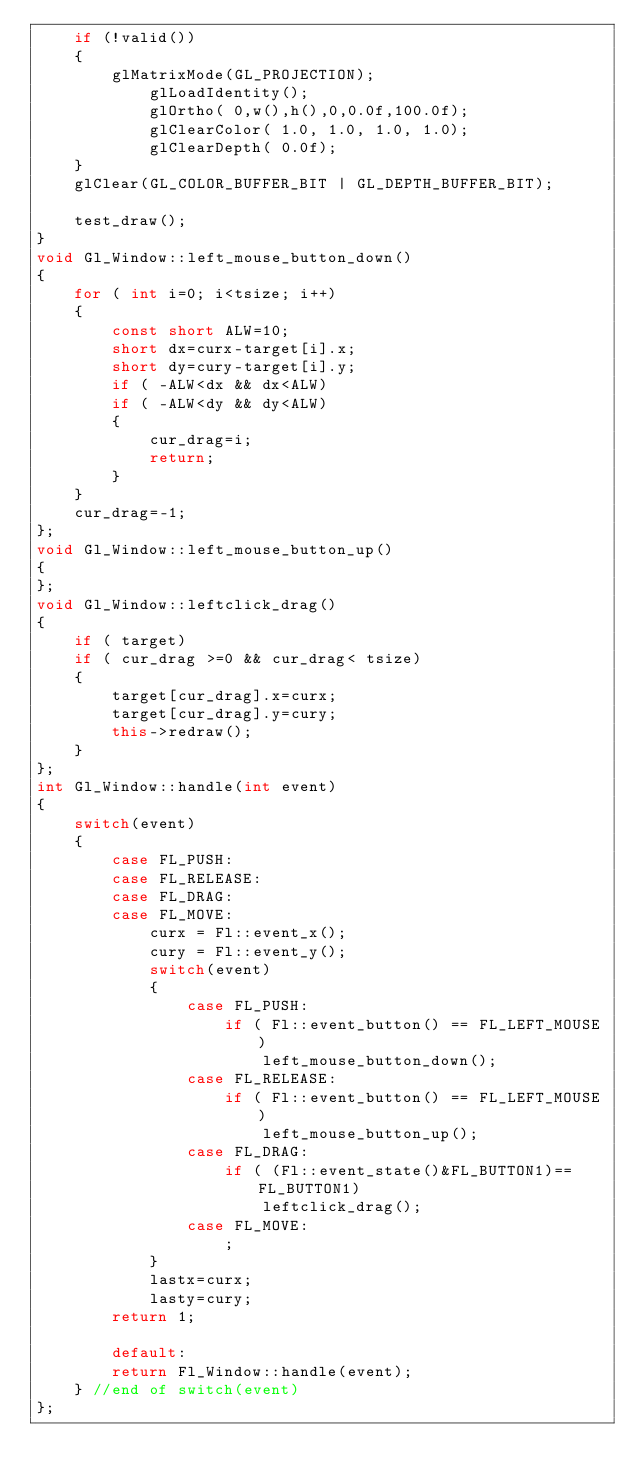Convert code to text. <code><loc_0><loc_0><loc_500><loc_500><_C++_>	if (!valid())
	{
		glMatrixMode(GL_PROJECTION);
			glLoadIdentity();
			glOrtho( 0,w(),h(),0,0.0f,100.0f);
			glClearColor( 1.0, 1.0, 1.0, 1.0);
			glClearDepth( 0.0f);
	}
	glClear(GL_COLOR_BUFFER_BIT | GL_DEPTH_BUFFER_BIT);
	
	test_draw();
}
void Gl_Window::left_mouse_button_down()
{
	for ( int i=0; i<tsize; i++)
	{
		const short ALW=10;
		short dx=curx-target[i].x;
		short dy=cury-target[i].y;
		if ( -ALW<dx && dx<ALW)
		if ( -ALW<dy && dy<ALW)
		{
			cur_drag=i;
			return;
		}
	}
	cur_drag=-1;
};
void Gl_Window::left_mouse_button_up()
{
};
void Gl_Window::leftclick_drag()
{
	if ( target)
	if ( cur_drag >=0 && cur_drag< tsize)
	{
		target[cur_drag].x=curx;
		target[cur_drag].y=cury;
		this->redraw();
	}
};
int Gl_Window::handle(int event)
{
	switch(event)
	{
		case FL_PUSH:
		case FL_RELEASE:
		case FL_DRAG:
		case FL_MOVE:
			curx = Fl::event_x();
			cury = Fl::event_y();
			switch(event)
			{
				case FL_PUSH:
					if ( Fl::event_button() == FL_LEFT_MOUSE)
						left_mouse_button_down();
				case FL_RELEASE:
					if ( Fl::event_button() == FL_LEFT_MOUSE)
						left_mouse_button_up();
				case FL_DRAG:
					if ( (Fl::event_state()&FL_BUTTON1)==FL_BUTTON1)
						leftclick_drag();
				case FL_MOVE:
					;
			}
			lastx=curx;
			lasty=cury;
		return 1;
		
		default:
		return Fl_Window::handle(event);
	} //end of switch(event)
};
</code> 